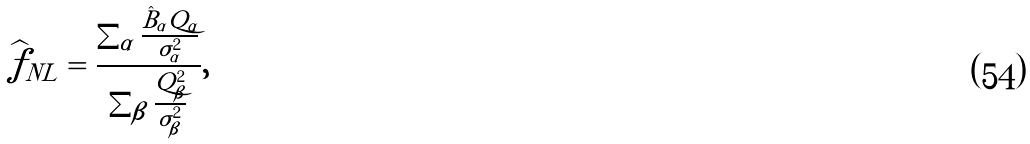<formula> <loc_0><loc_0><loc_500><loc_500>\widehat { f } _ { N L } = \frac { \sum _ { \alpha } \frac { \hat { B } _ { \alpha } Q _ { \alpha } } { \sigma ^ { 2 } _ { \alpha } } } { \sum _ { \beta } \frac { Q ^ { 2 } _ { \beta } } { \sigma ^ { 2 } _ { \beta } } } ,</formula> 